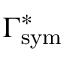Convert formula to latex. <formula><loc_0><loc_0><loc_500><loc_500>\Gamma _ { s y m } ^ { * }</formula> 